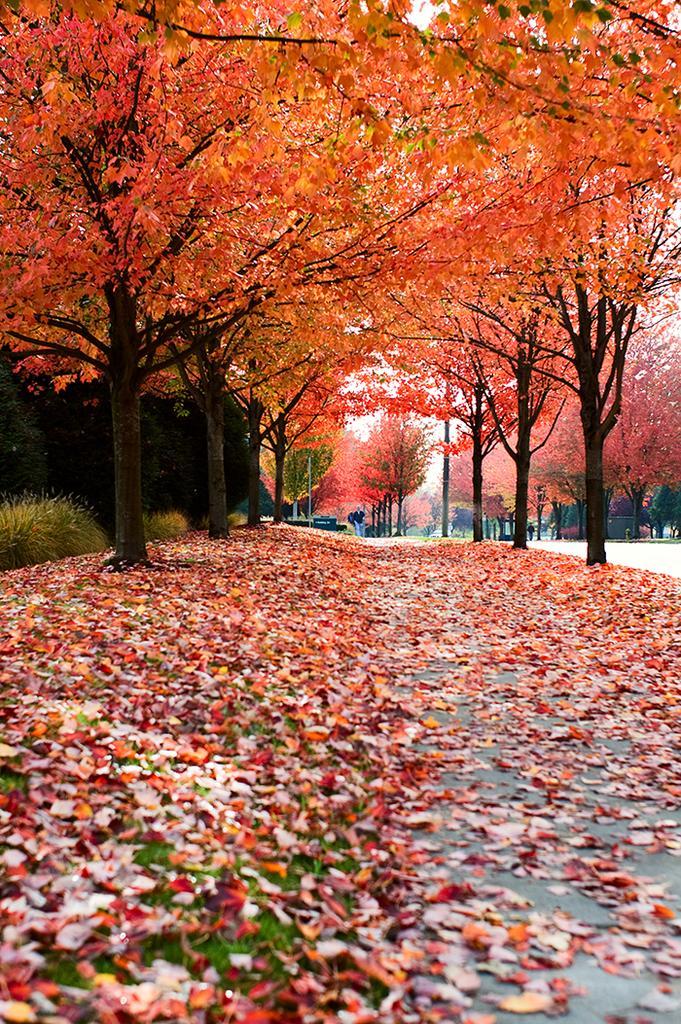Could you give a brief overview of what you see in this image? In this picture I can see the path in front, on which there are number of leaves and in the background I can see number of trees and on the left side of this image I can see the plants. 